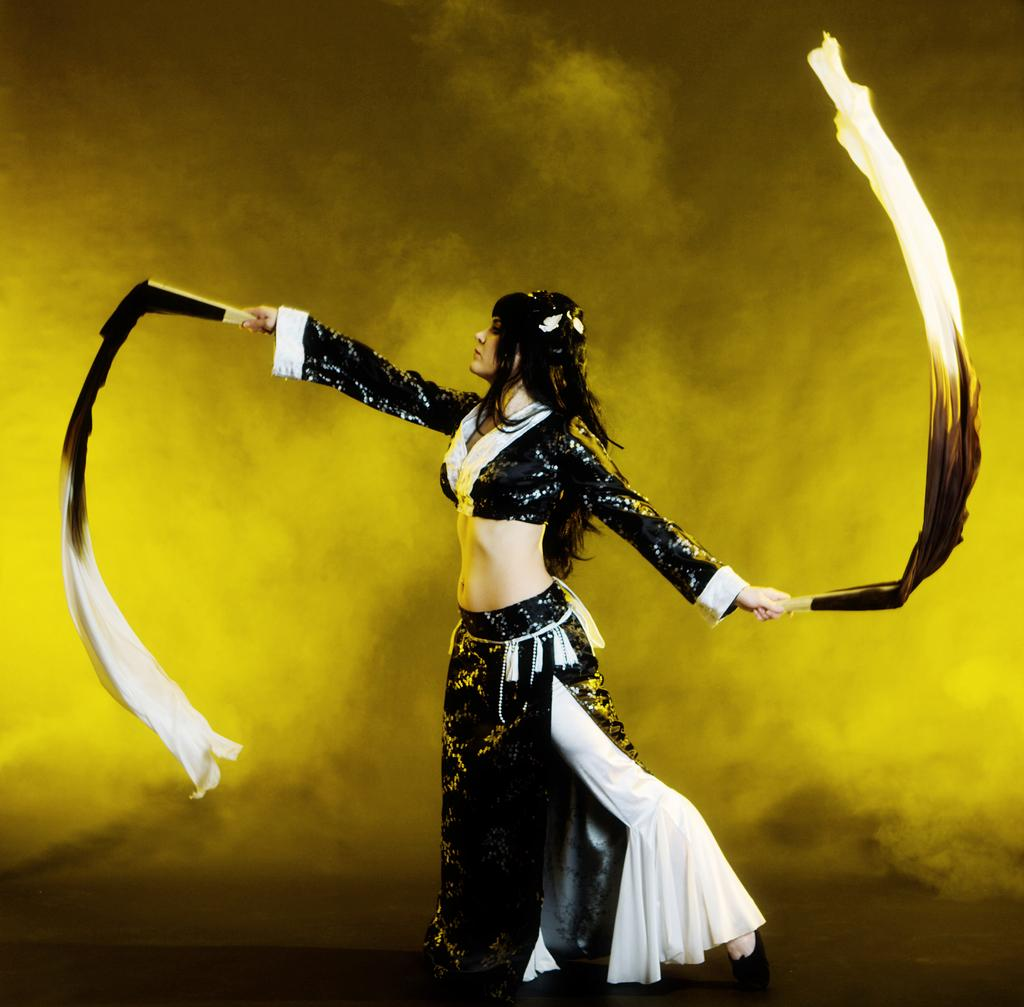What is the main subject of the image? There is a person in the image. What color is the background of the image? The background is yellow. What is the person in the image doing with her hands? The person is holding clothes with her hands. How many bricks can be seen in the image? There are no bricks present in the image. Is there a ghost visible in the image? There is no ghost present in the image. 